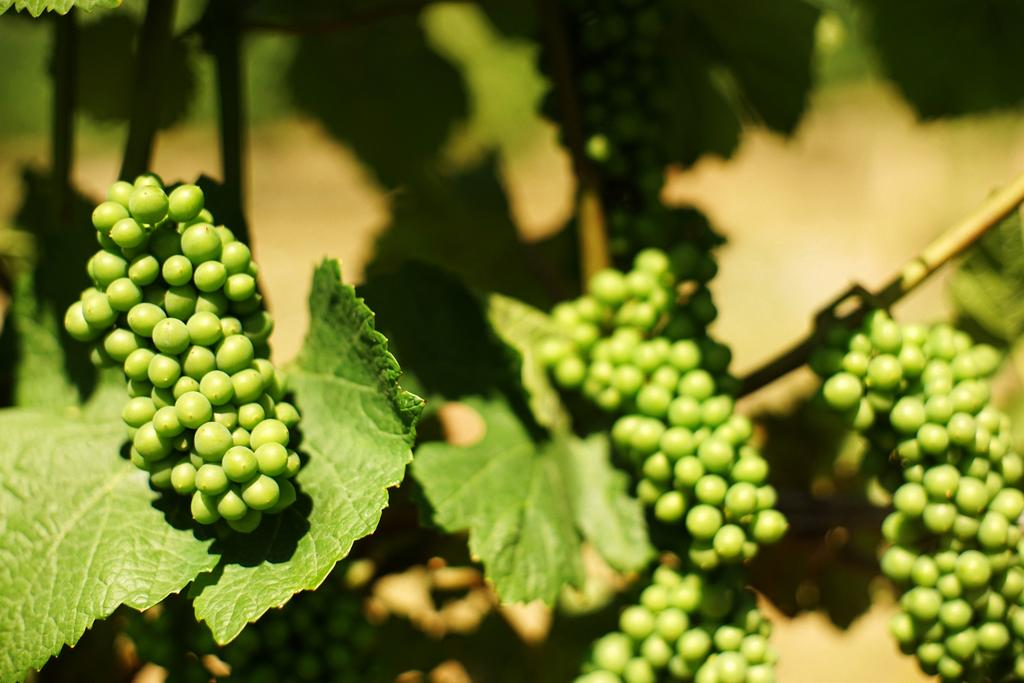What type of food items are present in the image? There are fruits in the picture. How are the fruits connected to the plant? The fruits are attached to stems. What other plant parts can be seen in the image? There are leafs in the picture. Can you describe the background of the image? The backdrop of the image is blurred. What type of music can be heard playing in the background of the image? There is no music present in the image, as it is a still photograph of fruits and leafs. 